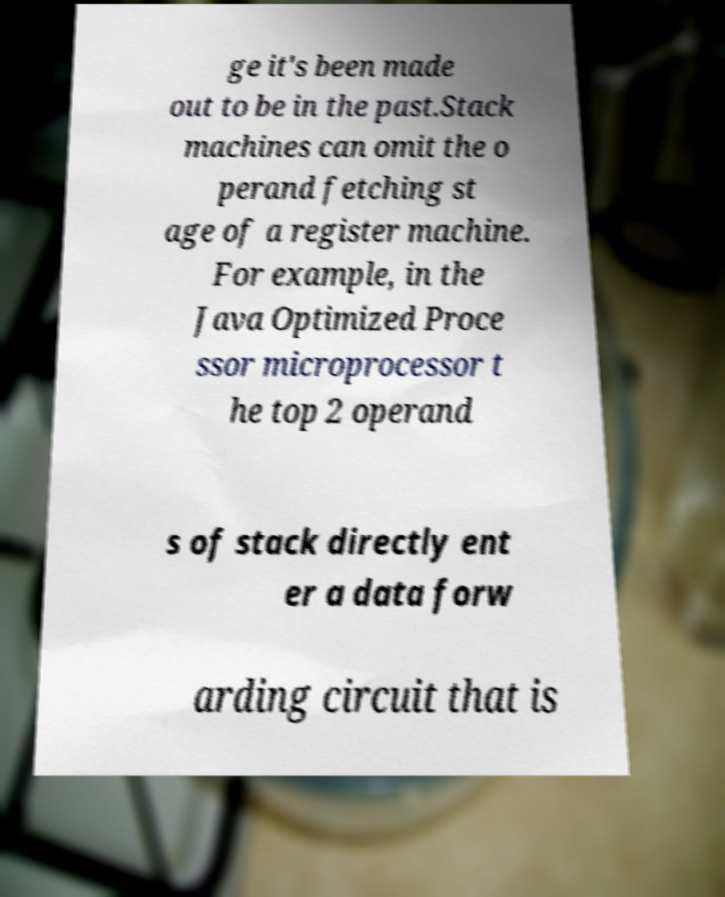Can you accurately transcribe the text from the provided image for me? ge it's been made out to be in the past.Stack machines can omit the o perand fetching st age of a register machine. For example, in the Java Optimized Proce ssor microprocessor t he top 2 operand s of stack directly ent er a data forw arding circuit that is 